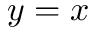Convert formula to latex. <formula><loc_0><loc_0><loc_500><loc_500>y = x</formula> 